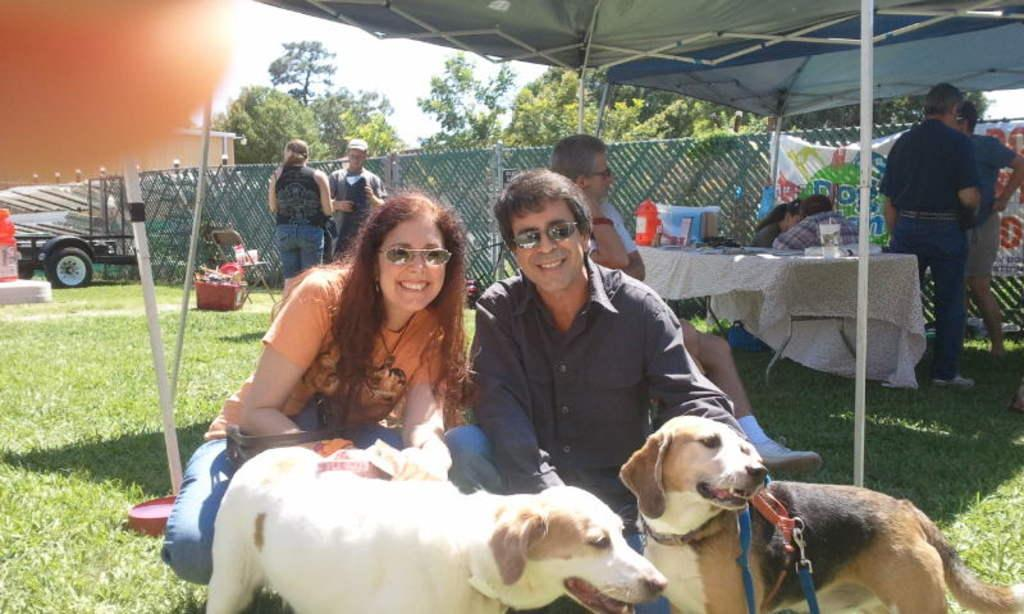How many dogs are present in the image? There are 2 dogs in the image. How many persons are present in the image? There are 2 persons in the image. Can you describe the background of the image? There are people standing in the background of the image. What type of furniture is visible in the image? There is a table in the image. What type of barrier is present in the image? There is a fence in the image. What type of plant is visible in the image? There is a tree in the image. What part of the natural environment is visible in the image? The sky is visible in the image. What type of transportation is present in the image? There is a vehicle in the image. Can you tell me how many giraffes are visible in the image? There are no giraffes present in the image. What type of iron object is visible in the image? There is no iron object present in the image. 